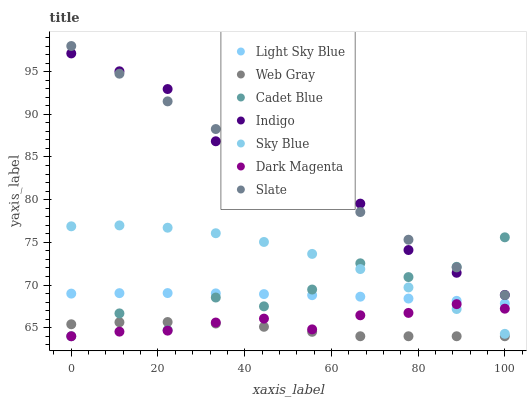Does Web Gray have the minimum area under the curve?
Answer yes or no. Yes. Does Indigo have the maximum area under the curve?
Answer yes or no. Yes. Does Dark Magenta have the minimum area under the curve?
Answer yes or no. No. Does Dark Magenta have the maximum area under the curve?
Answer yes or no. No. Is Slate the smoothest?
Answer yes or no. Yes. Is Cadet Blue the roughest?
Answer yes or no. Yes. Is Indigo the smoothest?
Answer yes or no. No. Is Indigo the roughest?
Answer yes or no. No. Does Cadet Blue have the lowest value?
Answer yes or no. Yes. Does Indigo have the lowest value?
Answer yes or no. No. Does Slate have the highest value?
Answer yes or no. Yes. Does Indigo have the highest value?
Answer yes or no. No. Is Dark Magenta less than Light Sky Blue?
Answer yes or no. Yes. Is Light Sky Blue greater than Web Gray?
Answer yes or no. Yes. Does Light Sky Blue intersect Sky Blue?
Answer yes or no. Yes. Is Light Sky Blue less than Sky Blue?
Answer yes or no. No. Is Light Sky Blue greater than Sky Blue?
Answer yes or no. No. Does Dark Magenta intersect Light Sky Blue?
Answer yes or no. No. 